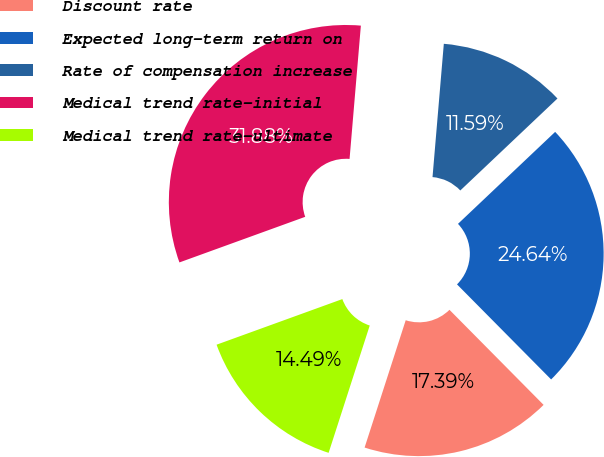Convert chart. <chart><loc_0><loc_0><loc_500><loc_500><pie_chart><fcel>Discount rate<fcel>Expected long-term return on<fcel>Rate of compensation increase<fcel>Medical trend rate-initial<fcel>Medical trend rate-ultimate<nl><fcel>17.39%<fcel>24.64%<fcel>11.59%<fcel>31.88%<fcel>14.49%<nl></chart> 